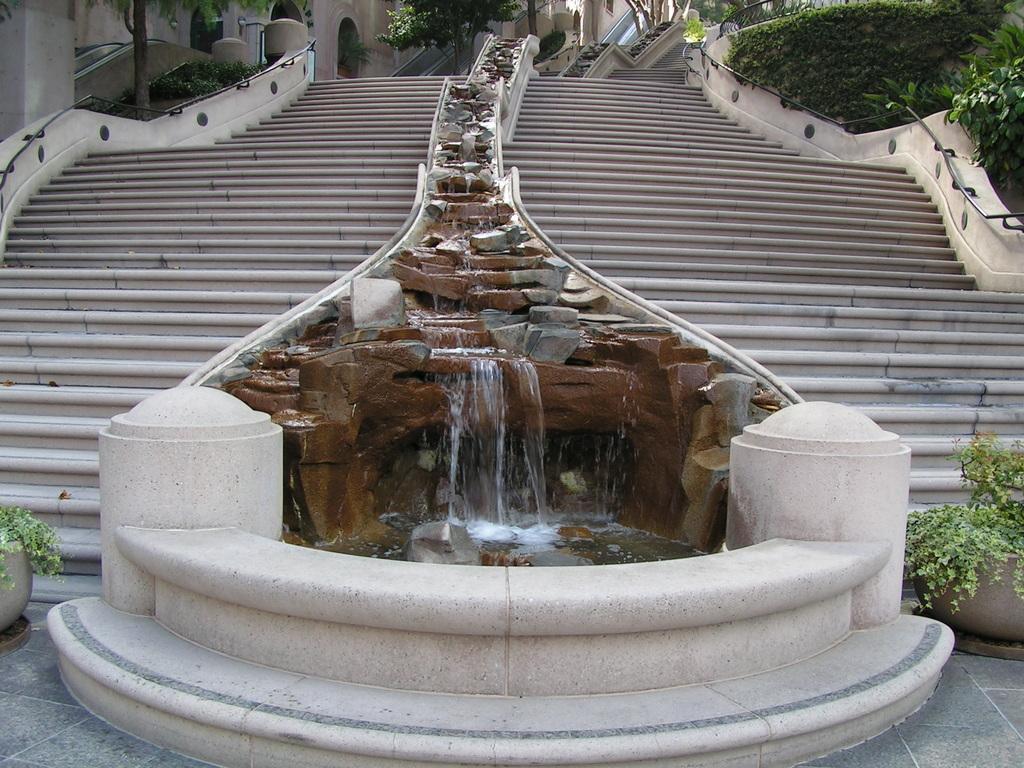Please provide a concise description of this image. In this picture we can see there is a staircase. In between the staircase there is a fountain. On the left and right side of the image there are trees, plants and pots. At the top of the image, it looks like a building. 